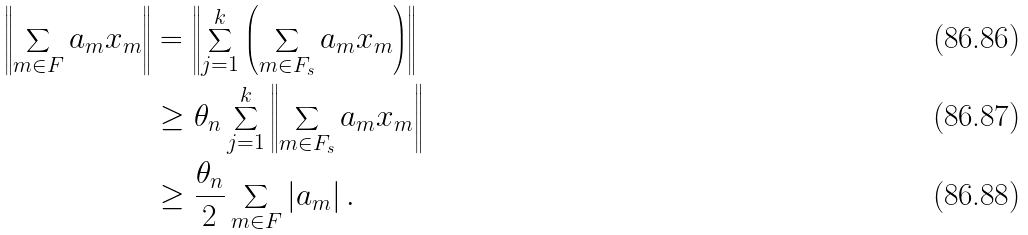Convert formula to latex. <formula><loc_0><loc_0><loc_500><loc_500>\left \| \sum _ { m \in F } a _ { m } x _ { m } \right \| & = \left \| \sum _ { j = 1 } ^ { k } \left ( \sum _ { m \in F _ { s } } a _ { m } x _ { m } \right ) \right \| \\ & \geq \theta _ { n } \sum _ { j = 1 } ^ { k } \left \| \sum _ { m \in F _ { s } } a _ { m } x _ { m } \right \| \\ & \geq \frac { \theta _ { n } } { 2 } \sum _ { m \in F } \left | a _ { m } \right | .</formula> 